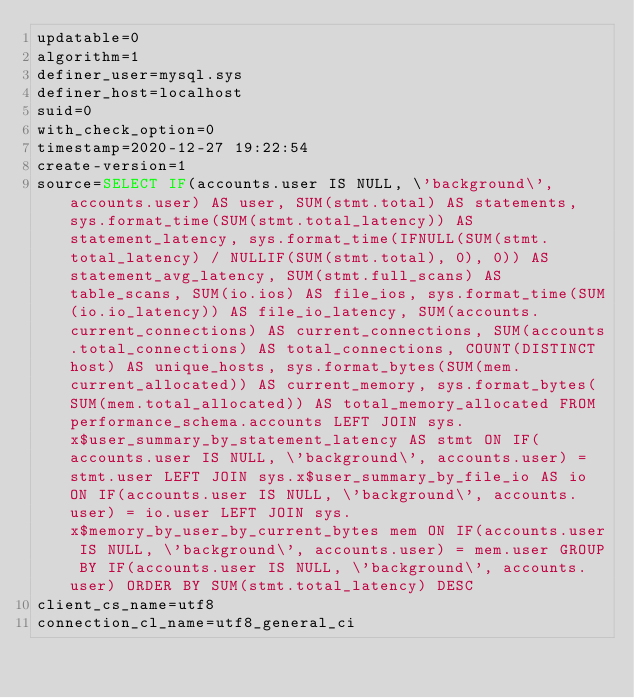Convert code to text. <code><loc_0><loc_0><loc_500><loc_500><_VisualBasic_>updatable=0
algorithm=1
definer_user=mysql.sys
definer_host=localhost
suid=0
with_check_option=0
timestamp=2020-12-27 19:22:54
create-version=1
source=SELECT IF(accounts.user IS NULL, \'background\', accounts.user) AS user, SUM(stmt.total) AS statements, sys.format_time(SUM(stmt.total_latency)) AS statement_latency, sys.format_time(IFNULL(SUM(stmt.total_latency) / NULLIF(SUM(stmt.total), 0), 0)) AS statement_avg_latency, SUM(stmt.full_scans) AS table_scans, SUM(io.ios) AS file_ios, sys.format_time(SUM(io.io_latency)) AS file_io_latency, SUM(accounts.current_connections) AS current_connections, SUM(accounts.total_connections) AS total_connections, COUNT(DISTINCT host) AS unique_hosts, sys.format_bytes(SUM(mem.current_allocated)) AS current_memory, sys.format_bytes(SUM(mem.total_allocated)) AS total_memory_allocated FROM performance_schema.accounts LEFT JOIN sys.x$user_summary_by_statement_latency AS stmt ON IF(accounts.user IS NULL, \'background\', accounts.user) = stmt.user LEFT JOIN sys.x$user_summary_by_file_io AS io ON IF(accounts.user IS NULL, \'background\', accounts.user) = io.user LEFT JOIN sys.x$memory_by_user_by_current_bytes mem ON IF(accounts.user IS NULL, \'background\', accounts.user) = mem.user GROUP BY IF(accounts.user IS NULL, \'background\', accounts.user) ORDER BY SUM(stmt.total_latency) DESC
client_cs_name=utf8
connection_cl_name=utf8_general_ci</code> 